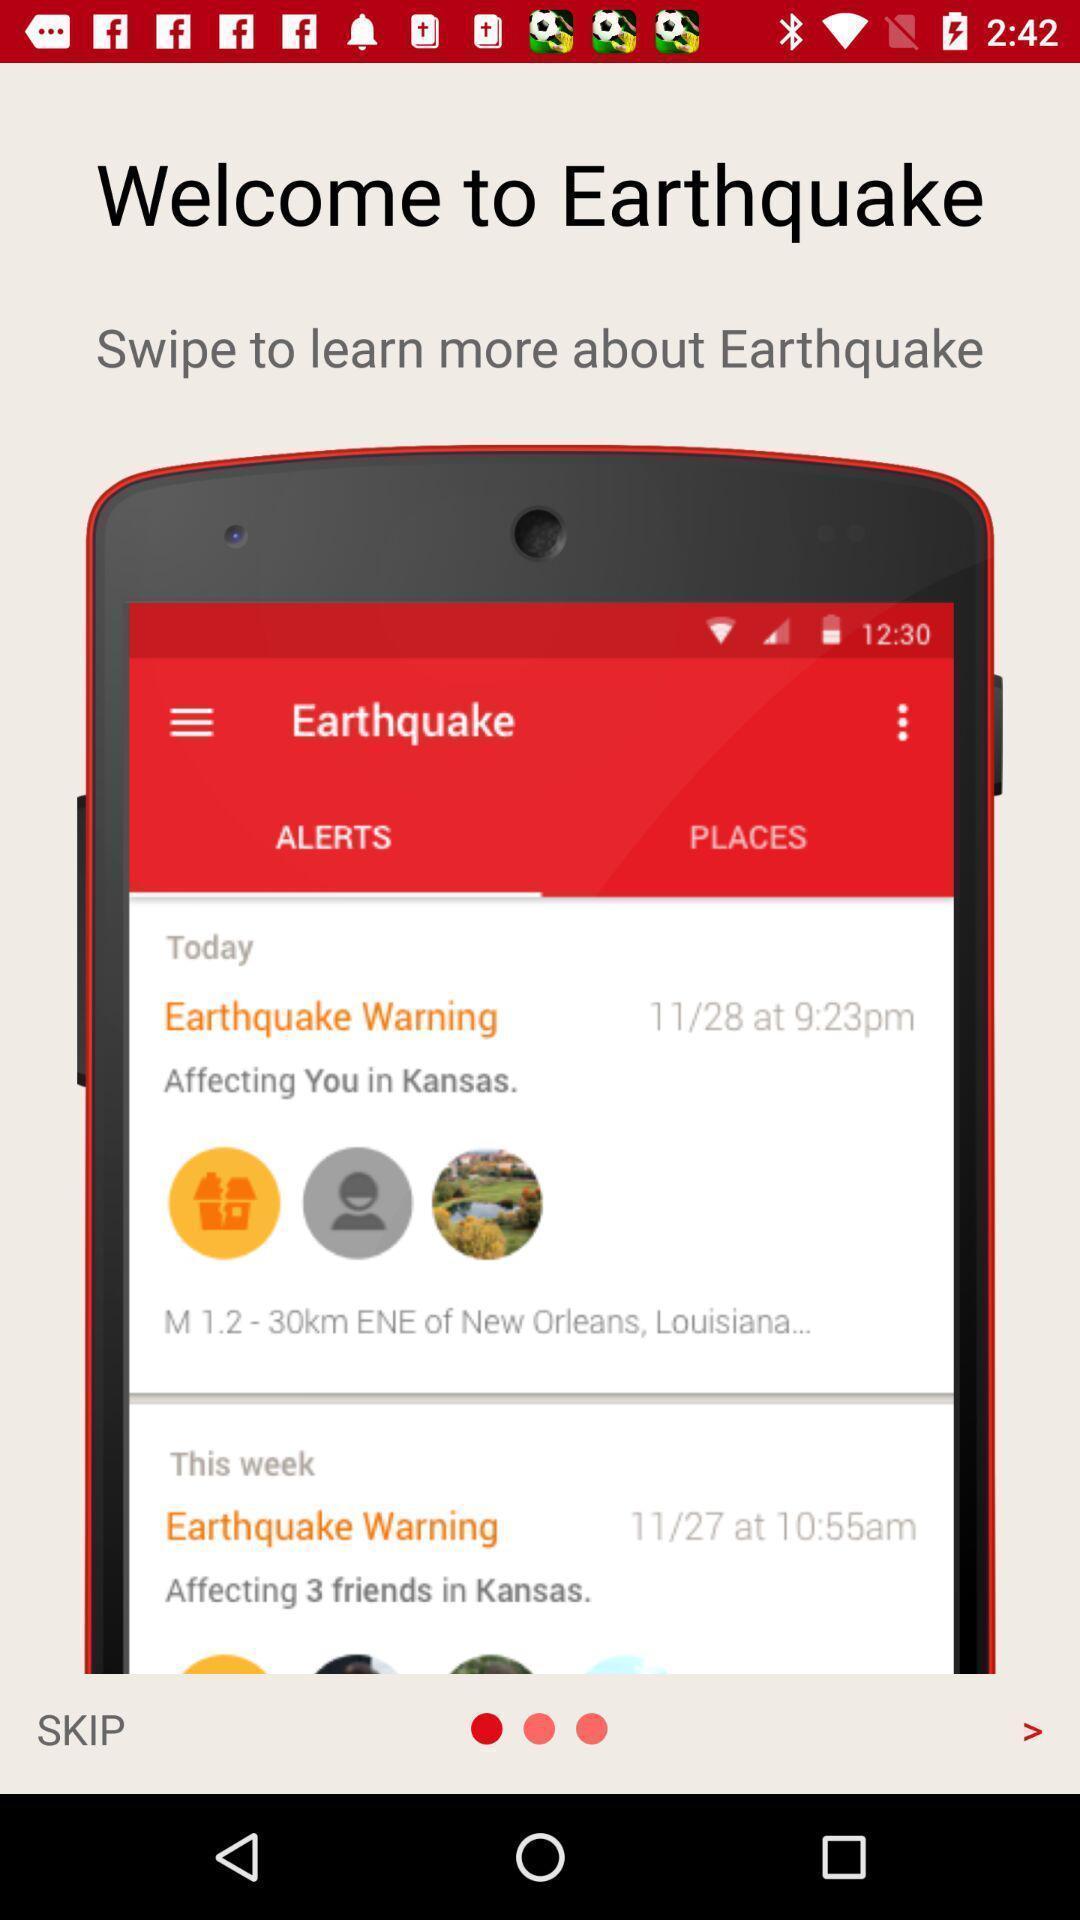Summarize the main components in this picture. Welcome page of a earthquake alert application. 